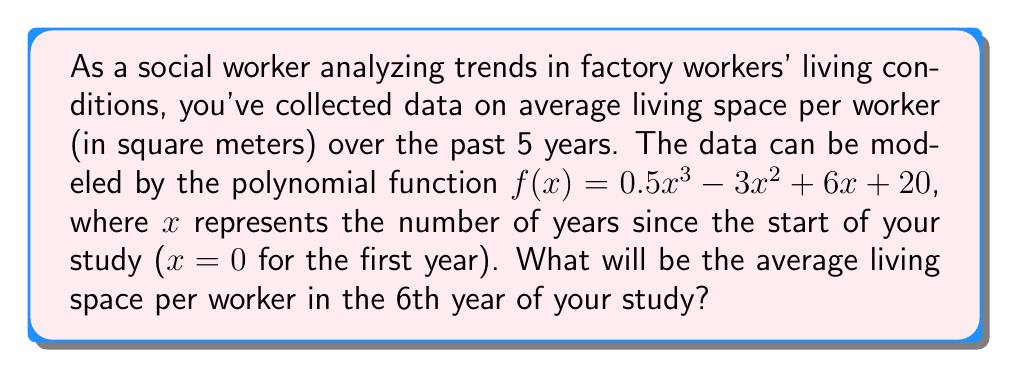Can you answer this question? To find the average living space per worker in the 6th year, we need to evaluate the function $f(x)$ at $x = 5$ (since $x = 0$ represents the first year, $x = 5$ represents the 6th year). Let's follow these steps:

1) We have the function $f(x) = 0.5x^3 - 3x^2 + 6x + 20$

2) We need to calculate $f(5)$:
   $f(5) = 0.5(5^3) - 3(5^2) + 6(5) + 20$

3) Let's evaluate each term:
   - $0.5(5^3) = 0.5 \cdot 125 = 62.5$
   - $3(5^2) = 3 \cdot 25 = 75$
   - $6(5) = 30$
   - The constant term is 20

4) Now, let's sum up these terms:
   $f(5) = 62.5 - 75 + 30 + 20 = 37.5$

Therefore, in the 6th year of the study, the average living space per worker will be 37.5 square meters.
Answer: 37.5 square meters 